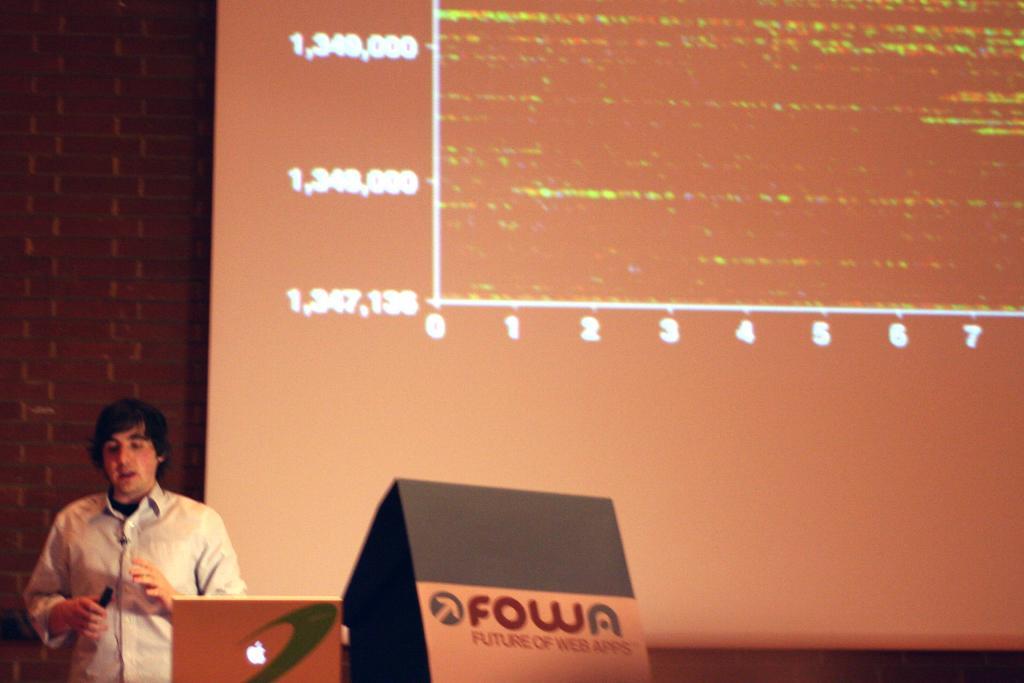How would you summarize this image in a sentence or two? In this image there is one person standing and holding a pen at bottom left corner of this image and there is one laptop is at bottom of this image, and there is a screen as we can see at right side of this image and there is a wall in the background. 